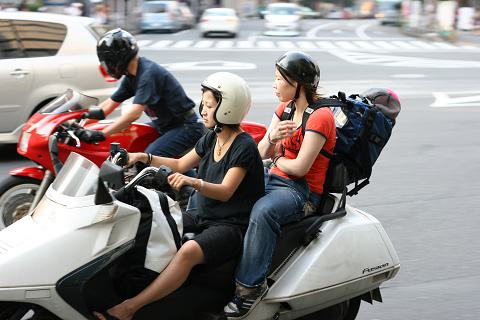What types of vehicles are currently visible in this image, and how do they contribute to the overall busy atmosphere? The image prominently features several motorcycles and a few cars, contributing to a sense of a crowded, active street scene typical of urban areas. The presence of these vehicles, along with visible pedestrians, suggests a bustling city environment where different forms of transport coexist, adding to the dynamic atmosphere of the location. 